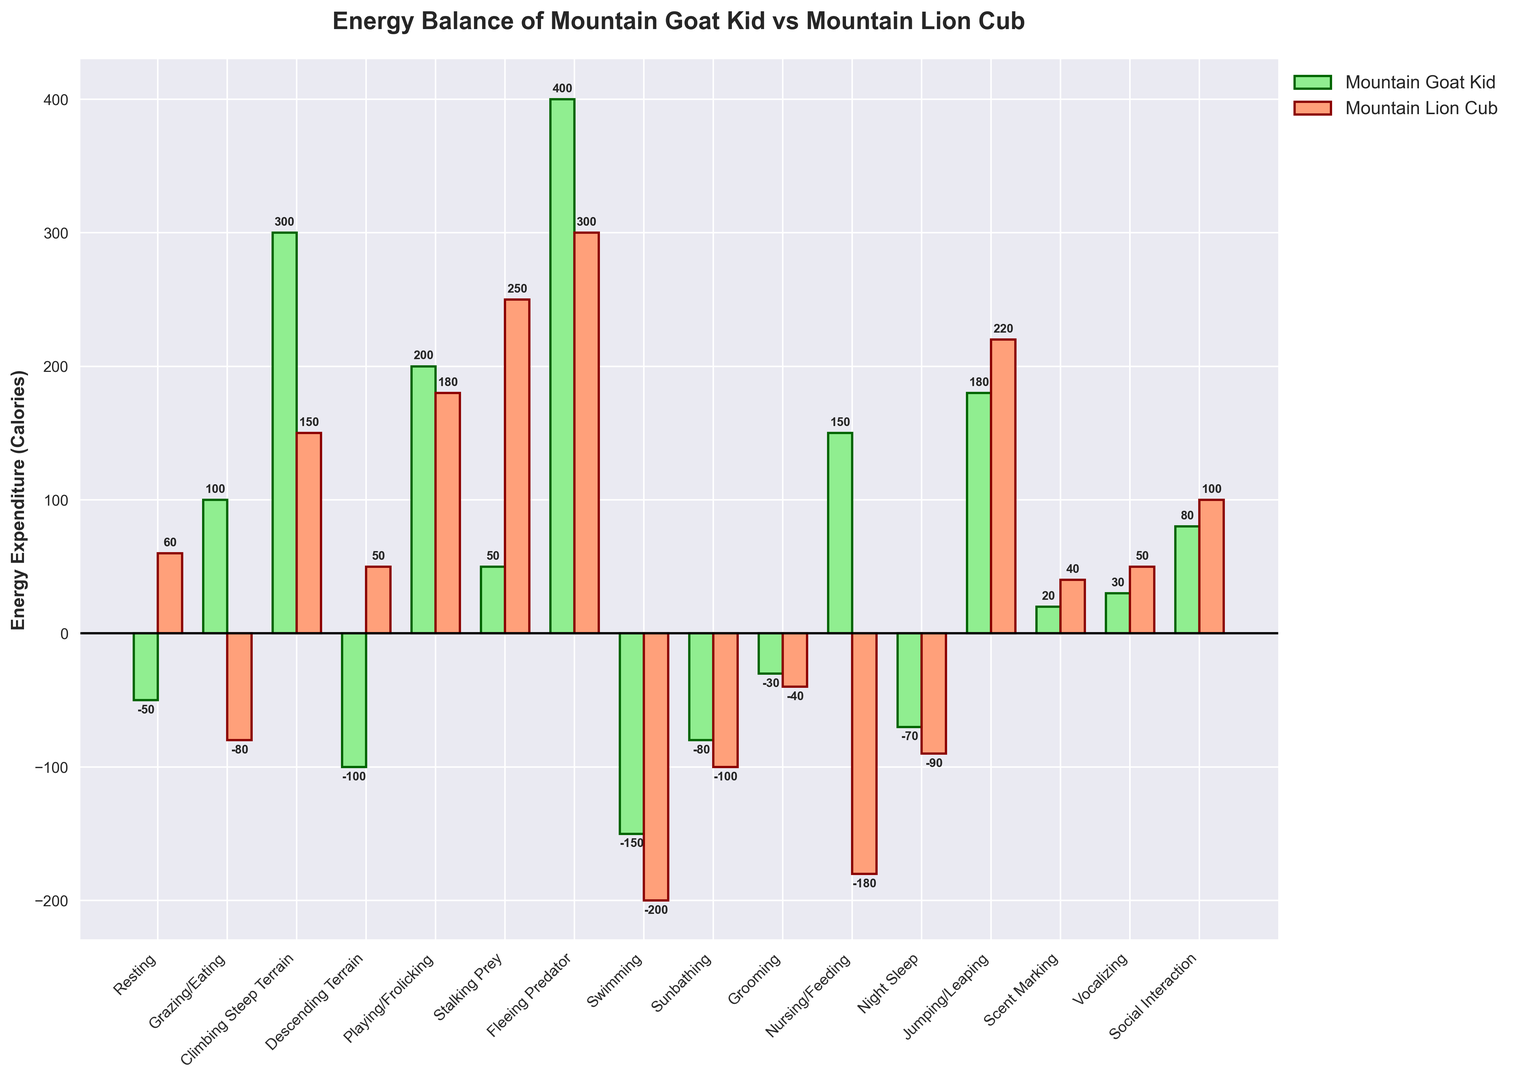Which activity shows the highest positive energy expenditure for the mountain goat kid? The highest positive bar for the mountain goat kid indicates the activity with the highest positive energy expenditure. The bar for "Fleeing Predator" is the highest positive bar.
Answer: Fleeing Predator Which activity shows the lowest positive energy expenditure for the mountain lion cub? The lowest positive bar for the mountain lion cub indicates the activity with the lowest positive energy expenditure. The bar for "Scent Marking" is the lowest positive bar.
Answer: Scent Marking Who expends more energy swimming, the mountain goat kid or the mountain lion cub? For swimming, compare the bars for the mountain goat kid and the mountain lion cub. The mountain goat kid has a bar of -150 while the mountain lion cub has -200. Thus, the mountain goat kid expends less energy (less negative).
Answer: Mountain Goat Kid What is the combined energy expenditure for both the mountain goat kid and mountain lion cub while climbing steep terrain? Summing the bars for climbing steep terrain: 300 (mountain goat kid) + 150 (mountain lion cub).
Answer: 450 What is the difference in energy expenditure between the two animals while playing/frolicking? Subtract the energy expenditure of the mountain lion cub from the mountain goat kid for playing/frolicking: 200 - 180.
Answer: 20 Which activity shows a negative energy balance for both the mountain goat kid and mountain lion cub? Identify the activities where both bars are below zero. "Swimming" and "Sunbathing" both have negative bars for both animals.
Answer: Swimming, Sunbathing How much more energy does the mountain lion cub use during stalking prey compared to the mountain goat kid? Subtract the mountain goat kid's energy expenditure from the mountain lion cub's energy expenditure for stalking prey: 250 - 50.
Answer: 200 What is the average energy expenditure of the mountain goat kid across all activities? Sum all the energy expenditure values for the mountain goat kid and divide by the number of activities: (-50 + 100 + 300 - 100 + 200 + 50 + 400 - 150 - 80 -30 +150 -70 +180 +20 +30 +80) / 16. The total is 1030, hence 1030 / 16.
Answer: 64.38 Who has a higher positive energy balance during social interaction? Compare the height of the bars for social interaction. The mountain lion cub has a bar of 100 while the mountain goat kid has 80. Thus, the mountain lion cub has a higher positive energy balance.
Answer: Mountain Lion Cub During nursing/feeding, which animal shows a negative calorie balance? Check if either bar for nursing/feeding is below zero. The mountain lion cub has a bar of -180, indicating a negative calorie balance.
Answer: Mountain Lion Cub 